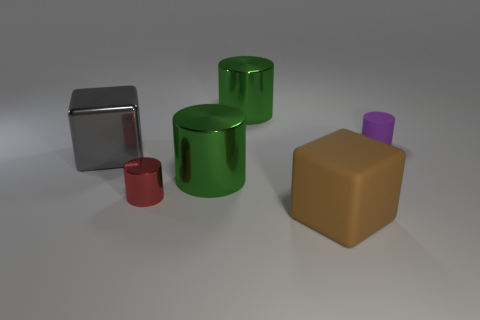Is there any other thing that has the same size as the red metallic thing?
Make the answer very short. Yes. How many other small things have the same shape as the tiny purple rubber object?
Provide a short and direct response. 1. There is a green cylinder that is behind the tiny purple matte thing; is it the same size as the rubber thing behind the brown matte cube?
Your answer should be compact. No. There is a small thing right of the tiny red object; what is its shape?
Provide a succinct answer. Cylinder. What material is the other small thing that is the same shape as the small red metal thing?
Give a very brief answer. Rubber. Is the size of the shiny cylinder that is behind the shiny cube the same as the brown block?
Make the answer very short. Yes. There is a small metal object; what number of things are to the right of it?
Keep it short and to the point. 4. Is the number of purple cylinders that are to the left of the red cylinder less than the number of things that are behind the big matte cube?
Your answer should be compact. Yes. What number of green metal cylinders are there?
Provide a succinct answer. 2. There is a object that is behind the purple cylinder; what is its color?
Give a very brief answer. Green. 